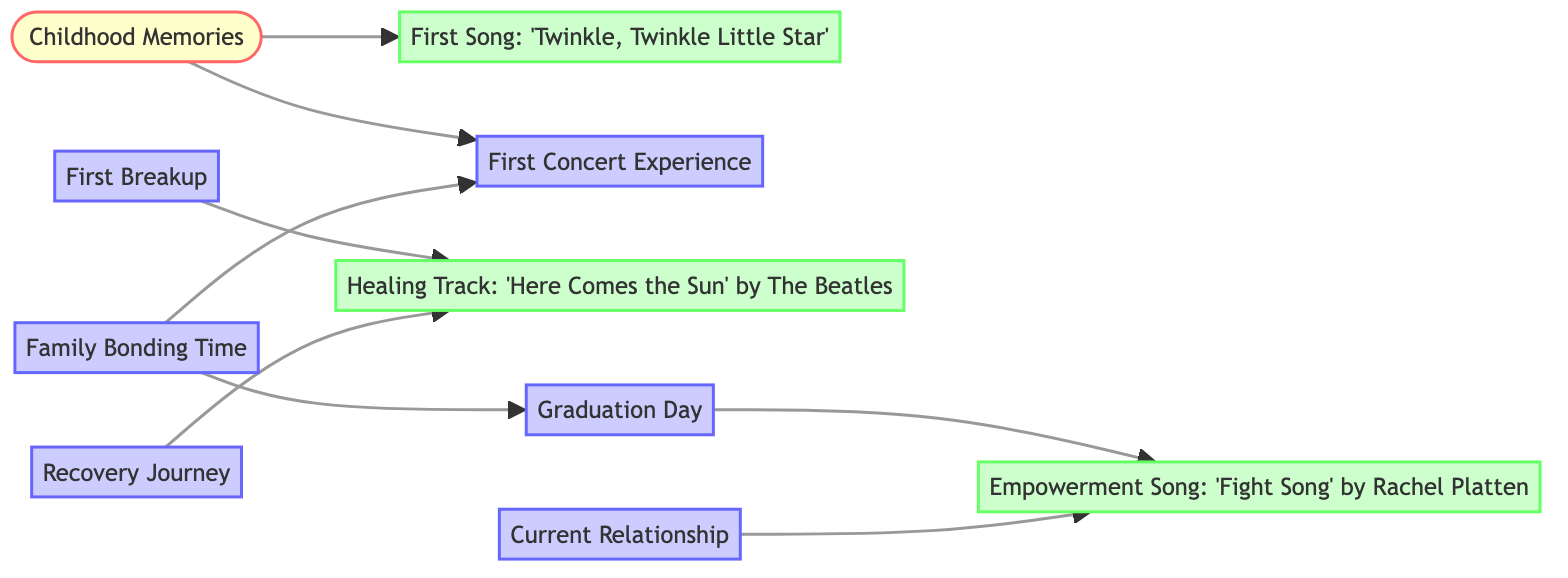What is the first song associated with childhood memories? The diagram specifies that the first song linked to childhood memories is "Twinkle, Twinkle Little Star." This is directly indicated by the edge connecting "Childhood" to "First Song."
Answer: "Twinkle, Twinkle Little Star" How many songs are listed in the diagram? There are four songs present in the nodes: "Twinkle, Twinkle Little Star," "Here Comes the Sun," "Fight Song," and "Here Comes the Sun." This can be counted from the song nodes in the diagram.
Answer: 4 Which event is directly connected to the first breakup? The diagram shows that "First Breakup" is directly connected to "Healing Track," indicating that the song is associated with that significant event. This relationship is represented by an edge going from "First Breakup" to "Healing Track."
Answer: Healing Track What songs are associated with the graduation day? The song connected to "Graduation Day" is "Fight Song," as indicated by the direct link from "Graduation" to "Empowerment Song." Therefore, "Fight Song" is associated with "Graduation Day."
Answer: Fight Song How many edges are there in the diagram? The diagram has a total of eight edges connecting various nodes. By counting the connections shown in the edges section of the diagram, this number includes all direct relationships between the events and songs.
Answer: 8 Which nodes are linked to "Family Bonding Time"? "Family Bonding Time" is connected to two events: "First Concert Experience" and "Graduation Day." This is shown by the two edges leading from "Family Bonding" to each of the event nodes in the diagram.
Answer: First Concert Experience, Graduation Day What is the relationship between the current relationship and the empowerment song? "Current Relationship" is linked to "Empowerment Song" through a direct edge, showing a connection between the two nodes. This indicates that the empowerment song is significant in the context of the current relationship.
Answer: Empowerment Song Which life event is linked to the healing track in multiple instances? The diagram shows that "Healing Track" is linked to both "First Breakup" and "Recovery Journey," indicating its significance in response to multiple life events. This can be observed through the two edges leading to "Healing Track."
Answer: First Breakup, Recovery Journey 